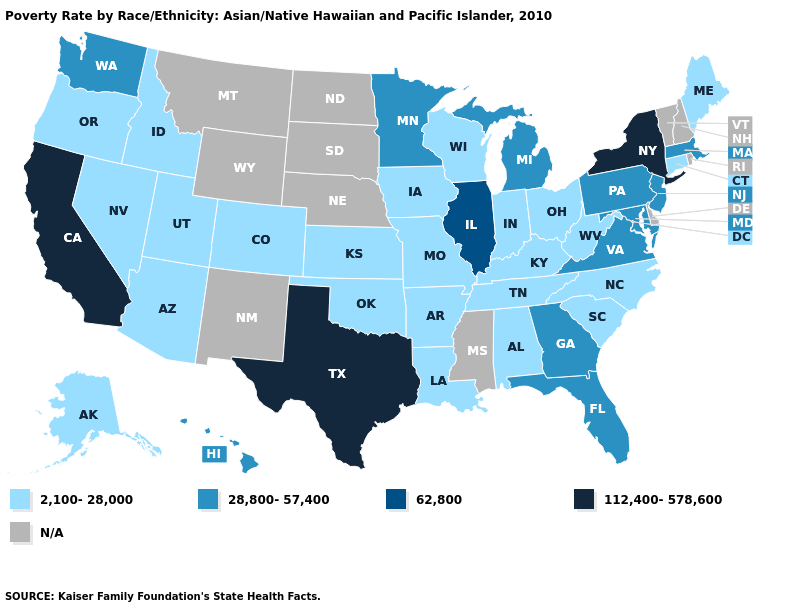Does Illinois have the highest value in the MidWest?
Answer briefly. Yes. Name the states that have a value in the range 28,800-57,400?
Write a very short answer. Florida, Georgia, Hawaii, Maryland, Massachusetts, Michigan, Minnesota, New Jersey, Pennsylvania, Virginia, Washington. Which states have the highest value in the USA?
Keep it brief. California, New York, Texas. Does the map have missing data?
Keep it brief. Yes. Name the states that have a value in the range 2,100-28,000?
Short answer required. Alabama, Alaska, Arizona, Arkansas, Colorado, Connecticut, Idaho, Indiana, Iowa, Kansas, Kentucky, Louisiana, Maine, Missouri, Nevada, North Carolina, Ohio, Oklahoma, Oregon, South Carolina, Tennessee, Utah, West Virginia, Wisconsin. Which states hav the highest value in the West?
Be succinct. California. What is the value of Michigan?
Answer briefly. 28,800-57,400. Name the states that have a value in the range N/A?
Keep it brief. Delaware, Mississippi, Montana, Nebraska, New Hampshire, New Mexico, North Dakota, Rhode Island, South Dakota, Vermont, Wyoming. Name the states that have a value in the range N/A?
Quick response, please. Delaware, Mississippi, Montana, Nebraska, New Hampshire, New Mexico, North Dakota, Rhode Island, South Dakota, Vermont, Wyoming. What is the value of California?
Answer briefly. 112,400-578,600. Among the states that border South Carolina , does Georgia have the highest value?
Concise answer only. Yes. How many symbols are there in the legend?
Give a very brief answer. 5. Does Connecticut have the lowest value in the USA?
Quick response, please. Yes. What is the value of Montana?
Concise answer only. N/A. What is the value of Connecticut?
Concise answer only. 2,100-28,000. 